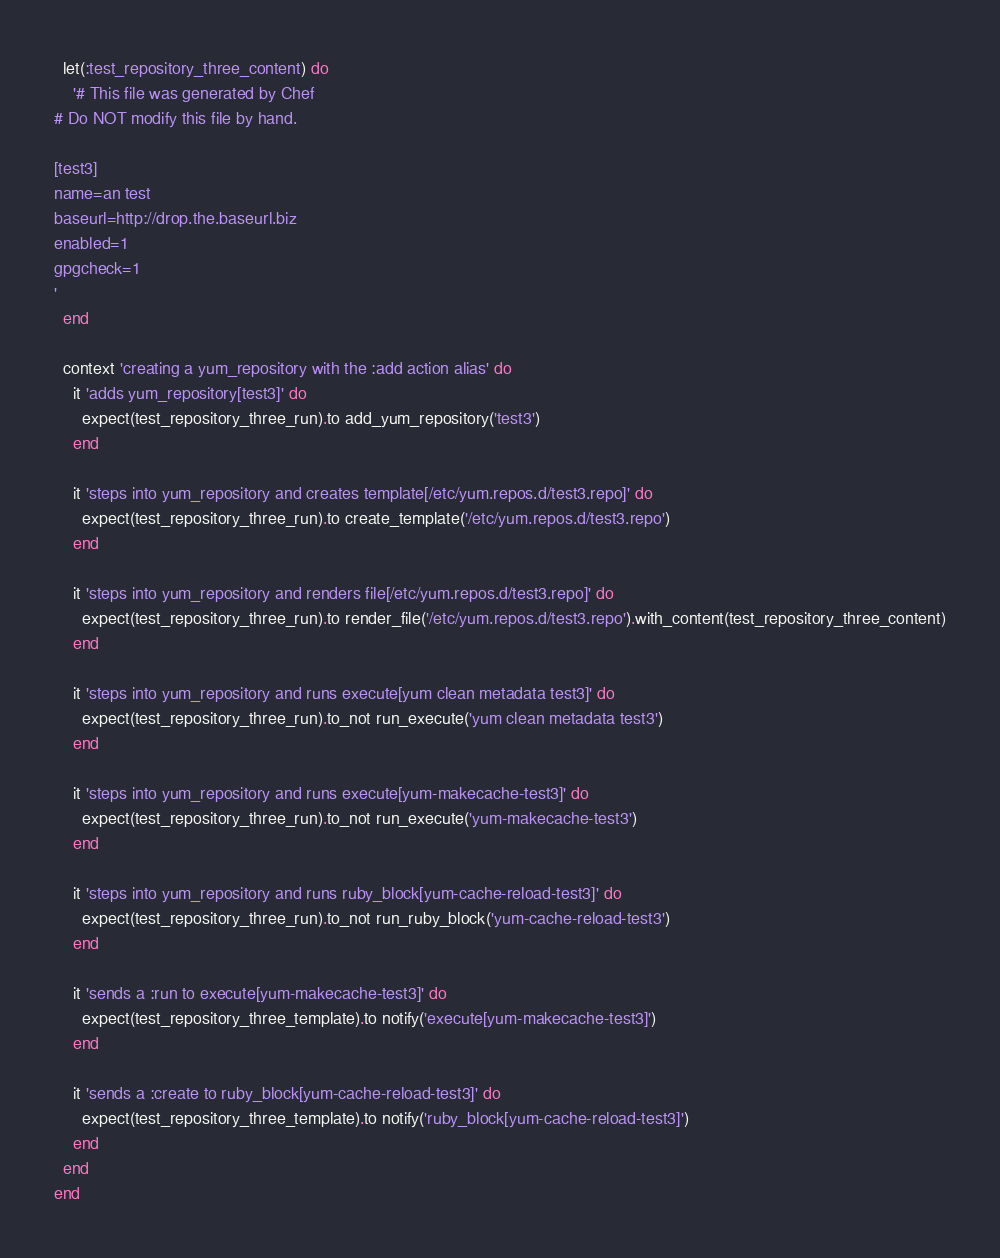Convert code to text. <code><loc_0><loc_0><loc_500><loc_500><_Ruby_>  let(:test_repository_three_content) do
    '# This file was generated by Chef
# Do NOT modify this file by hand.

[test3]
name=an test
baseurl=http://drop.the.baseurl.biz
enabled=1
gpgcheck=1
'
  end

  context 'creating a yum_repository with the :add action alias' do
    it 'adds yum_repository[test3]' do
      expect(test_repository_three_run).to add_yum_repository('test3')
    end

    it 'steps into yum_repository and creates template[/etc/yum.repos.d/test3.repo]' do
      expect(test_repository_three_run).to create_template('/etc/yum.repos.d/test3.repo')
    end

    it 'steps into yum_repository and renders file[/etc/yum.repos.d/test3.repo]' do
      expect(test_repository_three_run).to render_file('/etc/yum.repos.d/test3.repo').with_content(test_repository_three_content)
    end

    it 'steps into yum_repository and runs execute[yum clean metadata test3]' do
      expect(test_repository_three_run).to_not run_execute('yum clean metadata test3')
    end

    it 'steps into yum_repository and runs execute[yum-makecache-test3]' do
      expect(test_repository_three_run).to_not run_execute('yum-makecache-test3')
    end

    it 'steps into yum_repository and runs ruby_block[yum-cache-reload-test3]' do
      expect(test_repository_three_run).to_not run_ruby_block('yum-cache-reload-test3')
    end

    it 'sends a :run to execute[yum-makecache-test3]' do
      expect(test_repository_three_template).to notify('execute[yum-makecache-test3]')
    end

    it 'sends a :create to ruby_block[yum-cache-reload-test3]' do
      expect(test_repository_three_template).to notify('ruby_block[yum-cache-reload-test3]')
    end
  end
end
</code> 